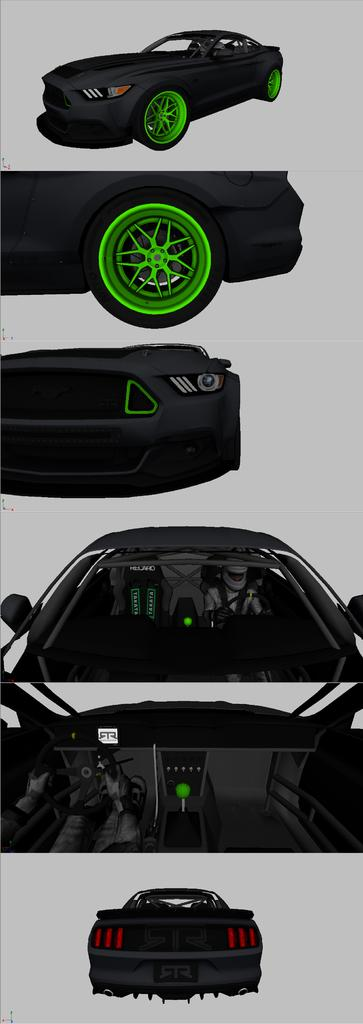What is the overall composition of the image? The image is a collage of different pictures. What is the common theme among the pictures in the collage? Each picture in the collage contains a part of a car. What type of army vehicles can be seen in the bushes in the image? There are no army vehicles or bushes present in the image; it is a collage of car parts. 